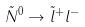Convert formula to latex. <formula><loc_0><loc_0><loc_500><loc_500>\tilde { N } ^ { 0 } \rightarrow \tilde { l } ^ { + } l ^ { - }</formula> 